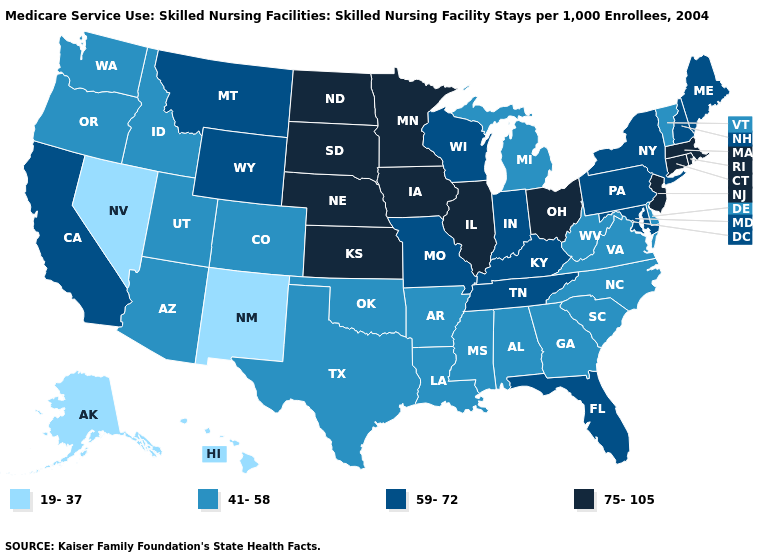Among the states that border New Hampshire , which have the highest value?
Keep it brief. Massachusetts. What is the value of California?
Short answer required. 59-72. Does Missouri have the highest value in the MidWest?
Quick response, please. No. What is the value of Wisconsin?
Answer briefly. 59-72. What is the lowest value in the Northeast?
Be succinct. 41-58. Which states have the lowest value in the USA?
Answer briefly. Alaska, Hawaii, Nevada, New Mexico. Among the states that border Wisconsin , does Michigan have the highest value?
Keep it brief. No. Which states have the lowest value in the Northeast?
Keep it brief. Vermont. What is the value of Rhode Island?
Short answer required. 75-105. Name the states that have a value in the range 41-58?
Keep it brief. Alabama, Arizona, Arkansas, Colorado, Delaware, Georgia, Idaho, Louisiana, Michigan, Mississippi, North Carolina, Oklahoma, Oregon, South Carolina, Texas, Utah, Vermont, Virginia, Washington, West Virginia. What is the value of Indiana?
Be succinct. 59-72. Which states have the highest value in the USA?
Short answer required. Connecticut, Illinois, Iowa, Kansas, Massachusetts, Minnesota, Nebraska, New Jersey, North Dakota, Ohio, Rhode Island, South Dakota. What is the value of Indiana?
Short answer required. 59-72. What is the value of California?
Write a very short answer. 59-72. 